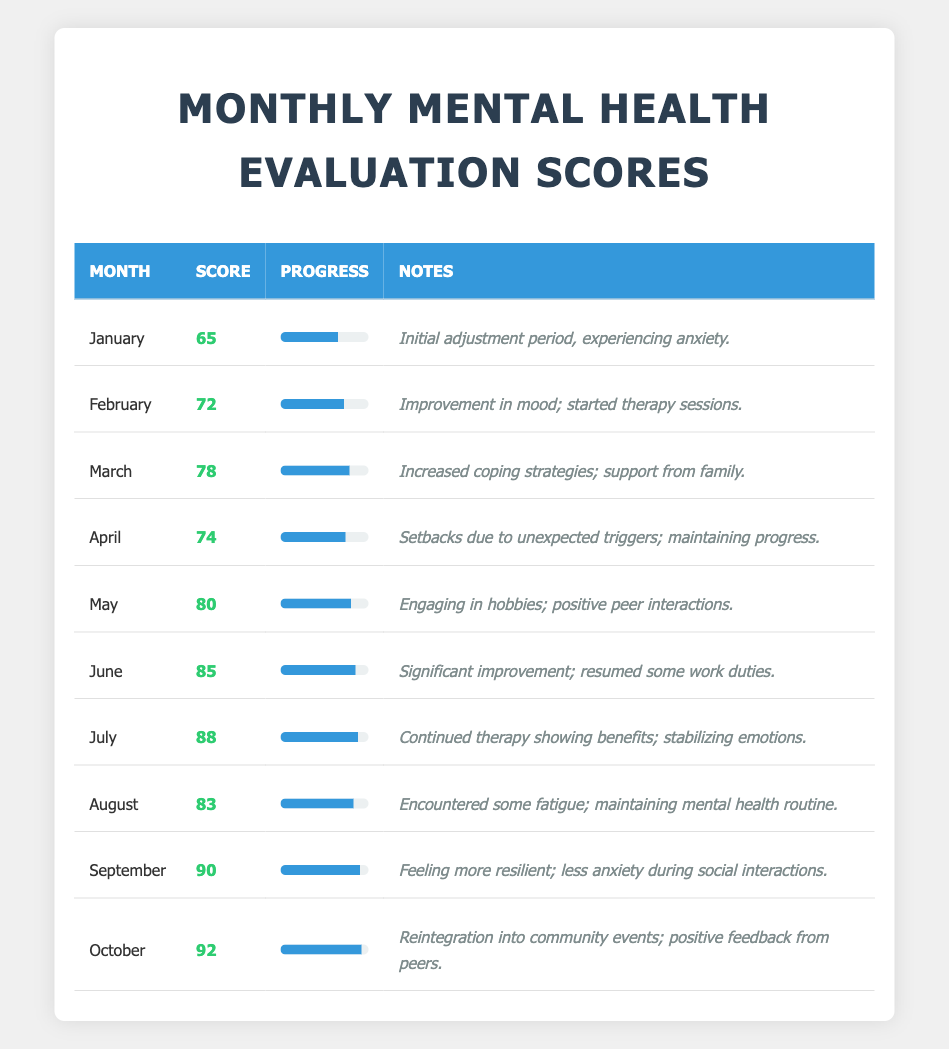What was the evaluation score in July? The table shows the score for each month. For July, the evaluation score is listed as 88.
Answer: 88 Which month had the lowest evaluation score? By reviewing the scores across all months, the lowest score is 65, which corresponds to January.
Answer: January What is the average evaluation score from May to October? To find the average, first sum the scores from May (80), June (85), July (88), August (83), September (90), and October (92): 80 + 85 + 88 + 83 + 90 + 92 = 518. There are 6 months, so the average is 518 / 6 = 86.33.
Answer: 86.33 Did any month have an evaluation score of 75? By checking the evaluation scores for each month, it is clear that there is no month that scored exactly 75.
Answer: No What was the increase in evaluation score from March to June? The score for March is 78 and the score for June is 85. To find the increase, subtract the March score from the June score: 85 - 78 = 7.
Answer: 7 How many months had a score above 80? By reviewing the scores in the table, the months with scores above 80 are June (85), July (88), August (83), September (90), and October (92). That totals to 5 months.
Answer: 5 Which month showed the most significant change compared to the previous month? Comparing each month's score to the previous month, the most significant change is from June (85) to July (88), which is an increase of 3. However, from February (72) to March (78), there was also an increase of 6. The largest change is therefore from February to March.
Answer: February to March What notes were provided for the month when the score was highest? The highest score of 92 corresponding to October has the notes: "Reintegration into community events; positive feedback from peers."
Answer: Reintegration into community events; positive feedback from peers 